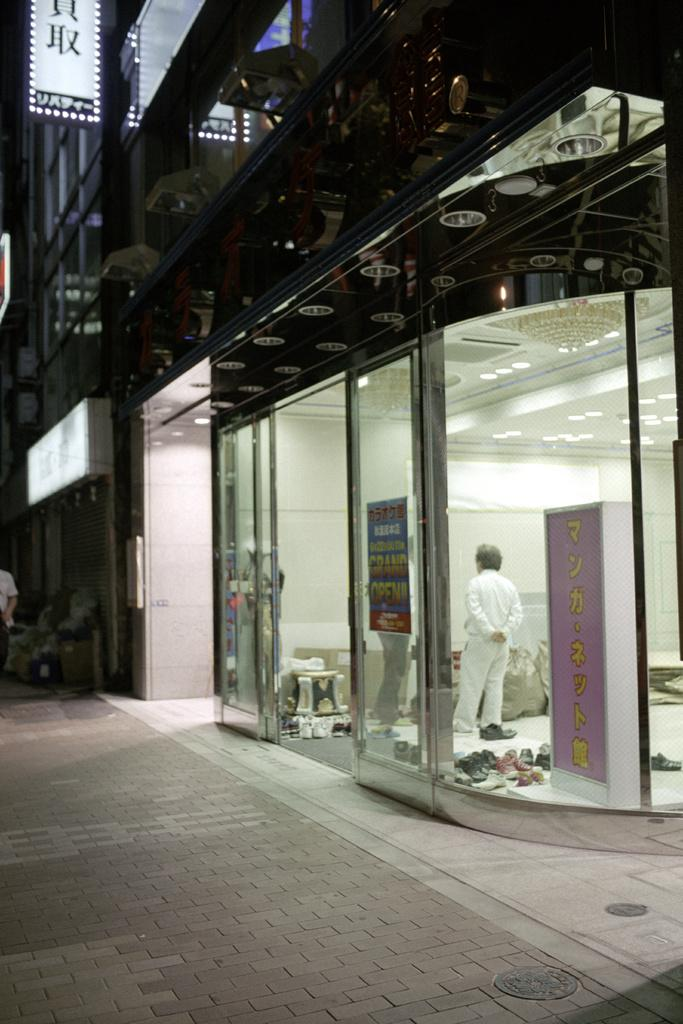How many people are present in the image? There are two persons standing inside the shop in the image. What type of lighting is present in the image? There are chandeliers and lights in the image. What can be found on the floor in the image? There are objects on the floor in the image. What type of signage is present in the image? There are boards in the image. What is visible in the background of the image? There are buildings visible in the image. What type of holiday is being celebrated in the image? There is no indication of a holiday being celebrated in the image. What type of humor can be seen in the image? There is no humor present in the image; it is a straightforward depiction of a shop interior. 